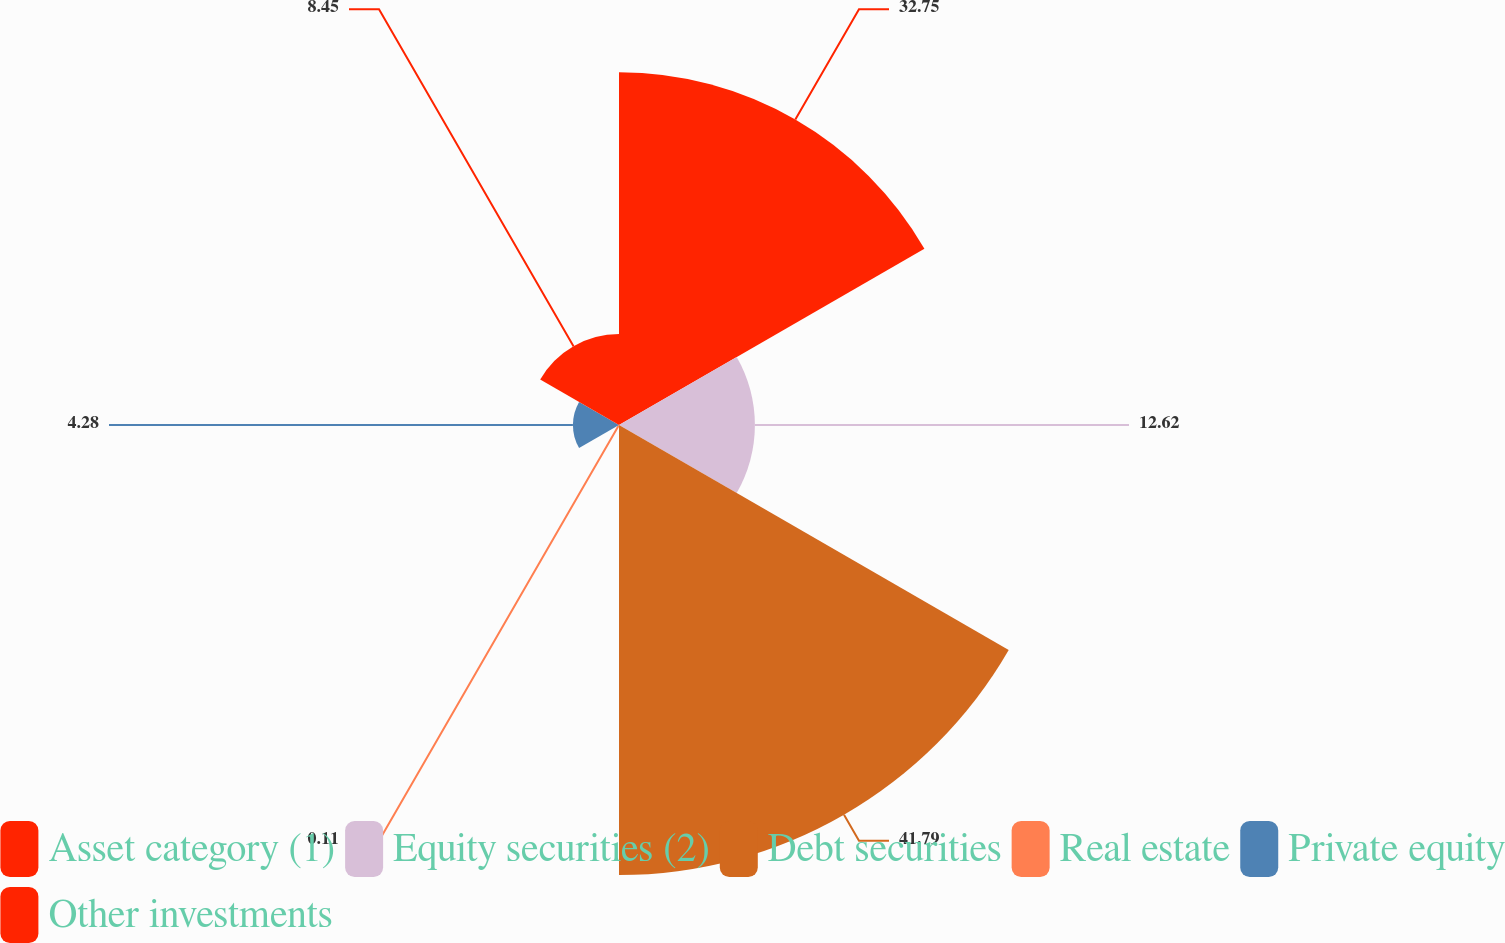<chart> <loc_0><loc_0><loc_500><loc_500><pie_chart><fcel>Asset category (1)<fcel>Equity securities (2)<fcel>Debt securities<fcel>Real estate<fcel>Private equity<fcel>Other investments<nl><fcel>32.75%<fcel>12.62%<fcel>41.79%<fcel>0.11%<fcel>4.28%<fcel>8.45%<nl></chart> 